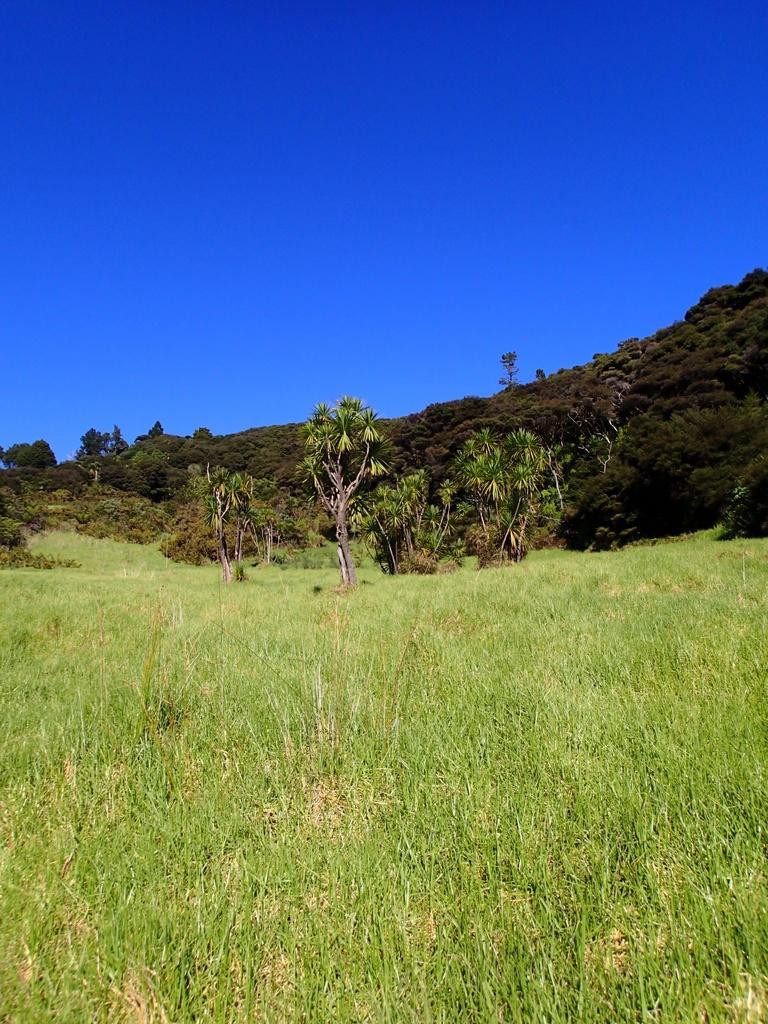Please provide a concise description of this image. This picture is clicked outside. In the foreground we can see the green grass and plants. In the center we can see the hills, plants and the green leaves. In the background we can see the sky. 